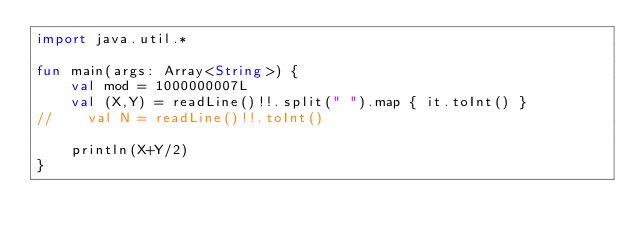<code> <loc_0><loc_0><loc_500><loc_500><_Kotlin_>import java.util.*

fun main(args: Array<String>) {
    val mod = 1000000007L
    val (X,Y) = readLine()!!.split(" ").map { it.toInt() }
//    val N = readLine()!!.toInt()

    println(X+Y/2)
}</code> 